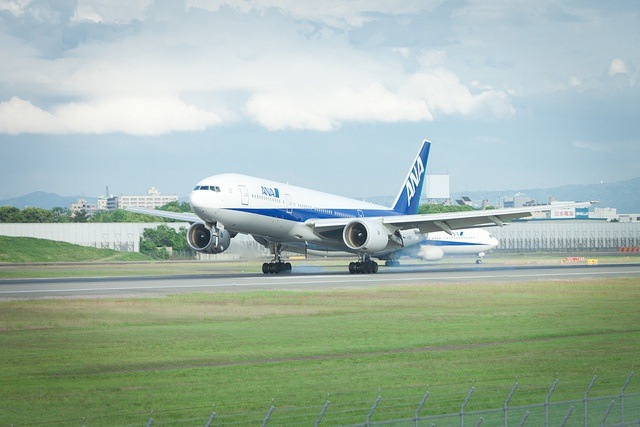Describe the objects in this image and their specific colors. I can see airplane in lightgray, white, gray, darkgray, and blue tones and airplane in lightgray, white, gray, and darkgray tones in this image. 